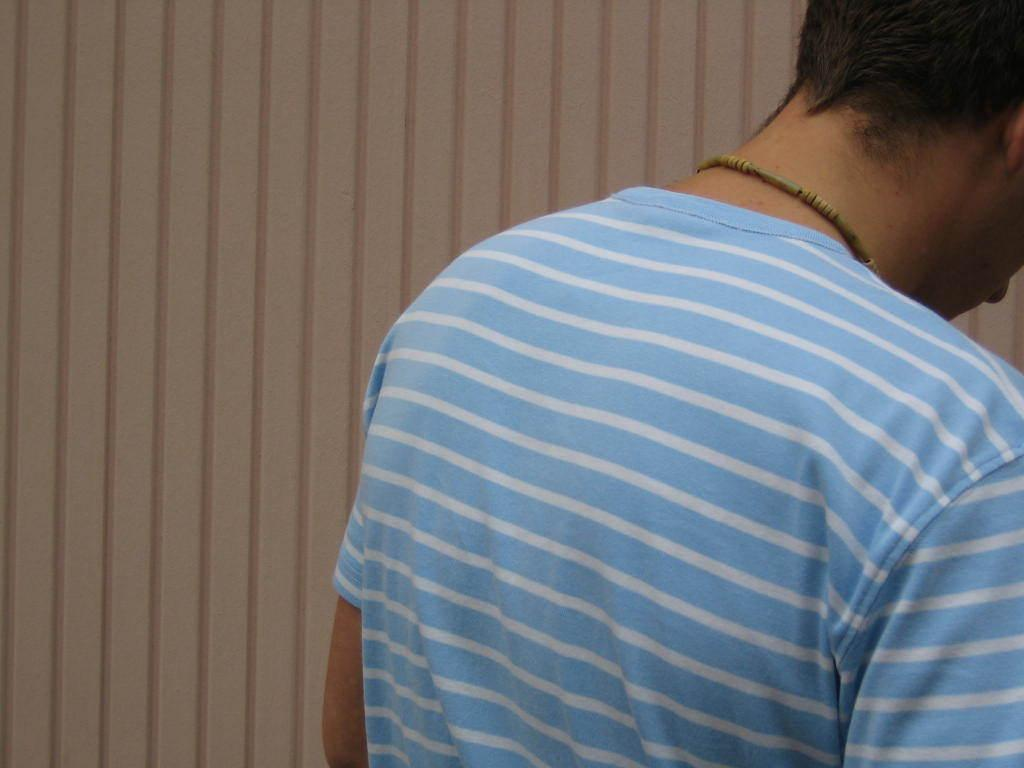Who or what is present in the image? There is a person in the image. What is the person wearing? The person is wearing a white and blue color dress. What can be seen in the background of the image? There is a wall visible in the background of the image. What is the rate of the basketball bounces in the image? There is no basketball present in the image, so it's not possible to determine the rate of any bounces. 